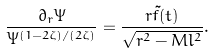Convert formula to latex. <formula><loc_0><loc_0><loc_500><loc_500>\frac { \partial _ { r } \Psi } { \Psi ^ { ( 1 - 2 \zeta ) / ( 2 \zeta ) } } = \frac { r \tilde { f } ( t ) } { \sqrt { r ^ { 2 } - M l ^ { 2 } } } .</formula> 